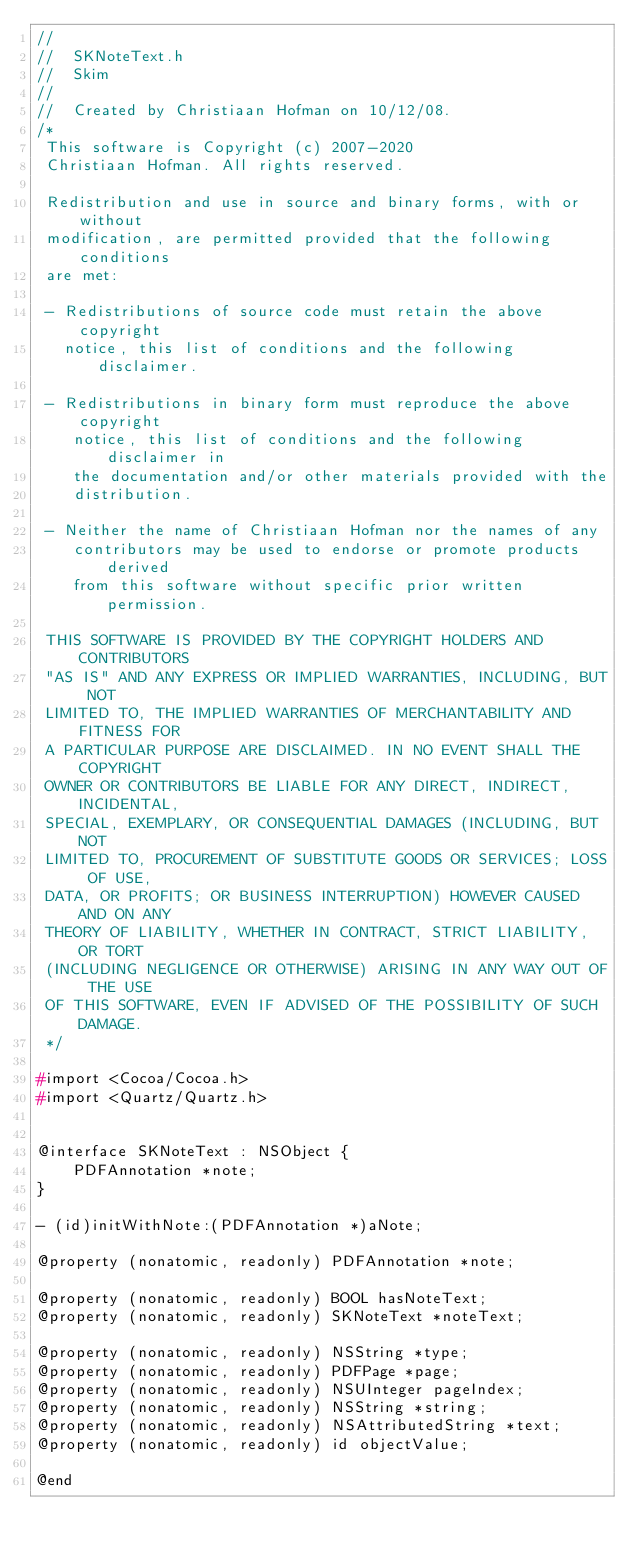Convert code to text. <code><loc_0><loc_0><loc_500><loc_500><_C_>//
//  SKNoteText.h
//  Skim
//
//  Created by Christiaan Hofman on 10/12/08.
/*
 This software is Copyright (c) 2007-2020
 Christiaan Hofman. All rights reserved.

 Redistribution and use in source and binary forms, with or without
 modification, are permitted provided that the following conditions
 are met:

 - Redistributions of source code must retain the above copyright
   notice, this list of conditions and the following disclaimer.

 - Redistributions in binary form must reproduce the above copyright
    notice, this list of conditions and the following disclaimer in
    the documentation and/or other materials provided with the
    distribution.

 - Neither the name of Christiaan Hofman nor the names of any
    contributors may be used to endorse or promote products derived
    from this software without specific prior written permission.

 THIS SOFTWARE IS PROVIDED BY THE COPYRIGHT HOLDERS AND CONTRIBUTORS
 "AS IS" AND ANY EXPRESS OR IMPLIED WARRANTIES, INCLUDING, BUT NOT
 LIMITED TO, THE IMPLIED WARRANTIES OF MERCHANTABILITY AND FITNESS FOR
 A PARTICULAR PURPOSE ARE DISCLAIMED. IN NO EVENT SHALL THE COPYRIGHT
 OWNER OR CONTRIBUTORS BE LIABLE FOR ANY DIRECT, INDIRECT, INCIDENTAL,
 SPECIAL, EXEMPLARY, OR CONSEQUENTIAL DAMAGES (INCLUDING, BUT NOT
 LIMITED TO, PROCUREMENT OF SUBSTITUTE GOODS OR SERVICES; LOSS OF USE,
 DATA, OR PROFITS; OR BUSINESS INTERRUPTION) HOWEVER CAUSED AND ON ANY
 THEORY OF LIABILITY, WHETHER IN CONTRACT, STRICT LIABILITY, OR TORT
 (INCLUDING NEGLIGENCE OR OTHERWISE) ARISING IN ANY WAY OUT OF THE USE
 OF THIS SOFTWARE, EVEN IF ADVISED OF THE POSSIBILITY OF SUCH DAMAGE.
 */

#import <Cocoa/Cocoa.h>
#import <Quartz/Quartz.h>


@interface SKNoteText : NSObject {
    PDFAnnotation *note;
}

- (id)initWithNote:(PDFAnnotation *)aNote;

@property (nonatomic, readonly) PDFAnnotation *note;

@property (nonatomic, readonly) BOOL hasNoteText;
@property (nonatomic, readonly) SKNoteText *noteText;

@property (nonatomic, readonly) NSString *type;
@property (nonatomic, readonly) PDFPage *page;
@property (nonatomic, readonly) NSUInteger pageIndex;
@property (nonatomic, readonly) NSString *string;
@property (nonatomic, readonly) NSAttributedString *text;
@property (nonatomic, readonly) id objectValue;

@end
</code> 